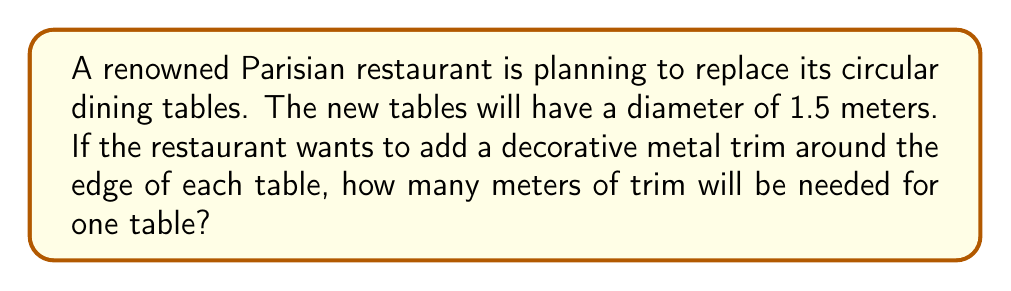Could you help me with this problem? To solve this problem, we need to calculate the circumference of a circular table. Let's approach this step-by-step:

1. Recall the formula for the circumference of a circle:
   $$C = \pi d$$
   where $C$ is the circumference, $\pi$ is pi (approximately 3.14159), and $d$ is the diameter.

2. We're given the diameter of the table:
   $d = 1.5$ meters

3. Substitute the values into the formula:
   $$C = \pi \times 1.5$$

4. Calculate:
   $$C \approx 3.14159 \times 1.5 = 4.71239$$

5. Round to two decimal places for practical use:
   $$C \approx 4.71$$ meters

Therefore, the restaurant will need approximately 4.71 meters of decorative metal trim for each table.
Answer: 4.71 meters 